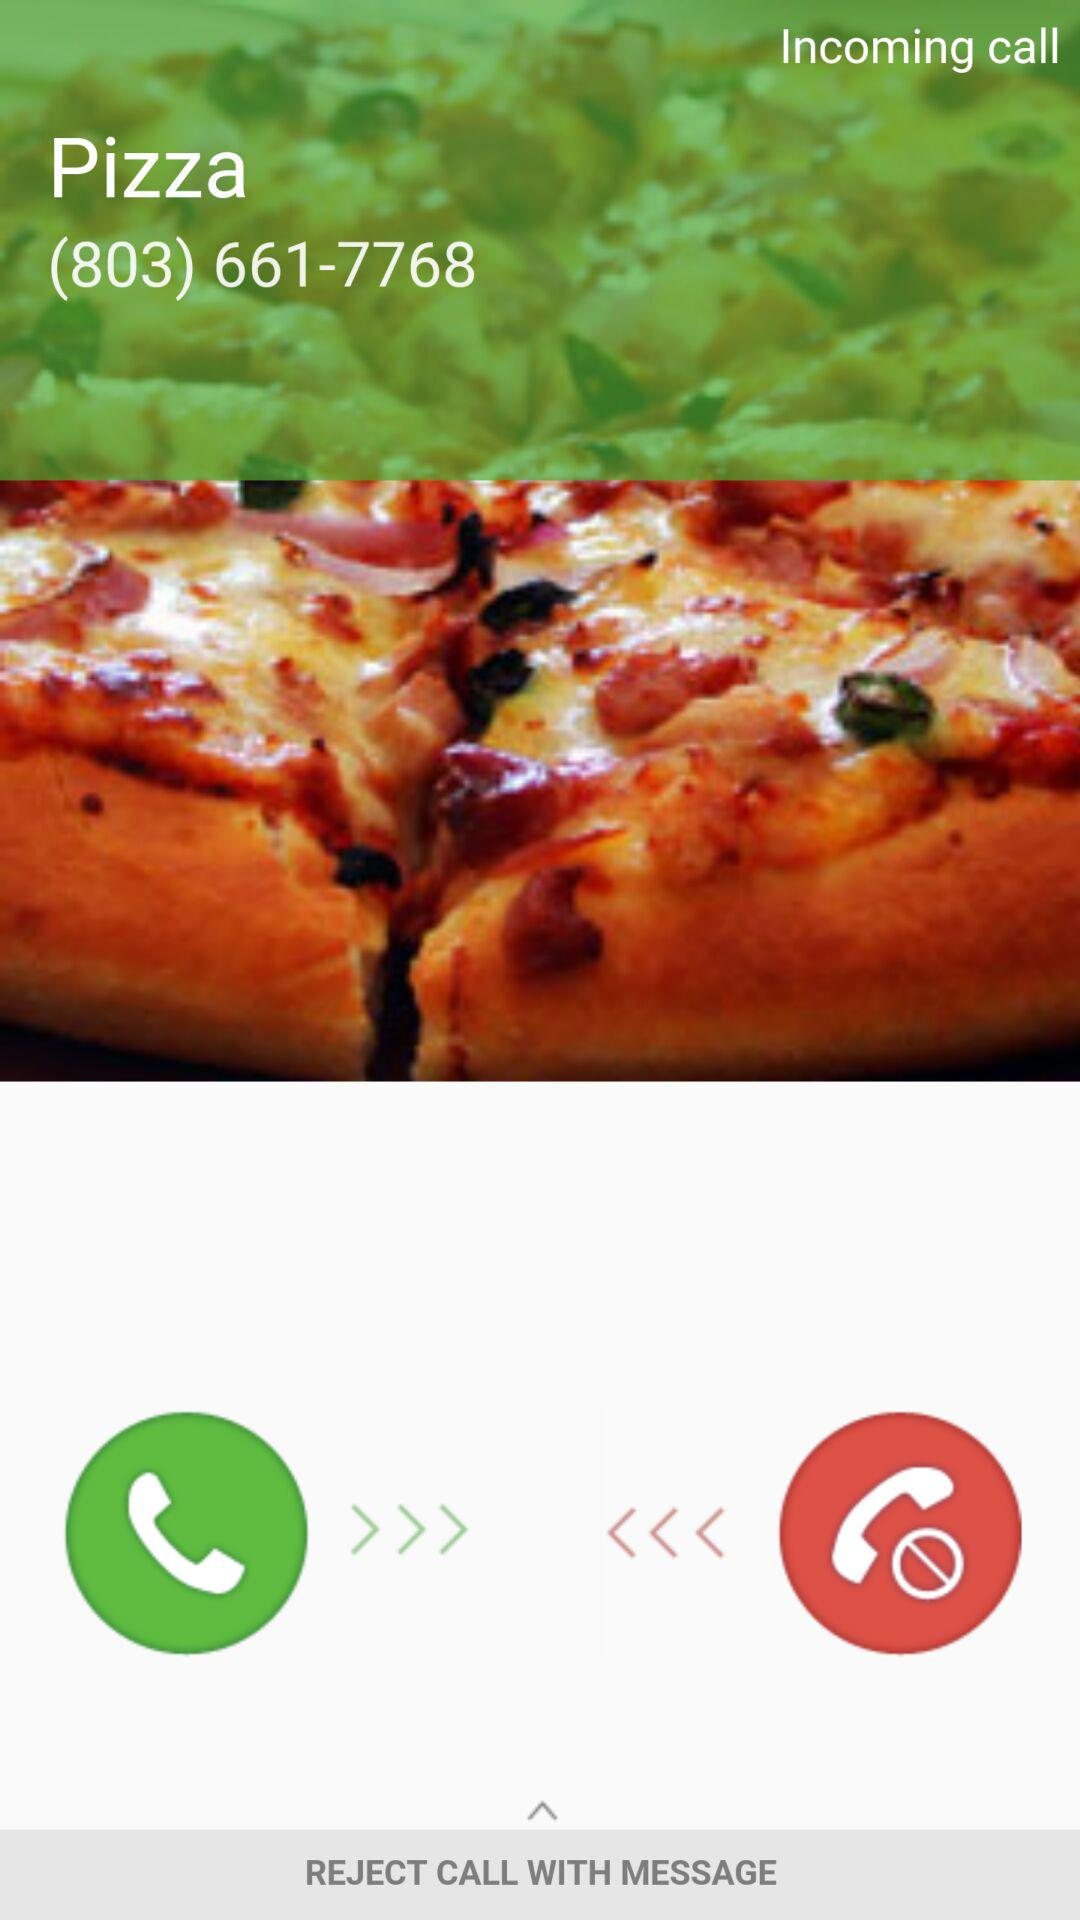What is the contact number? The contact number is (803) 661-7768. 